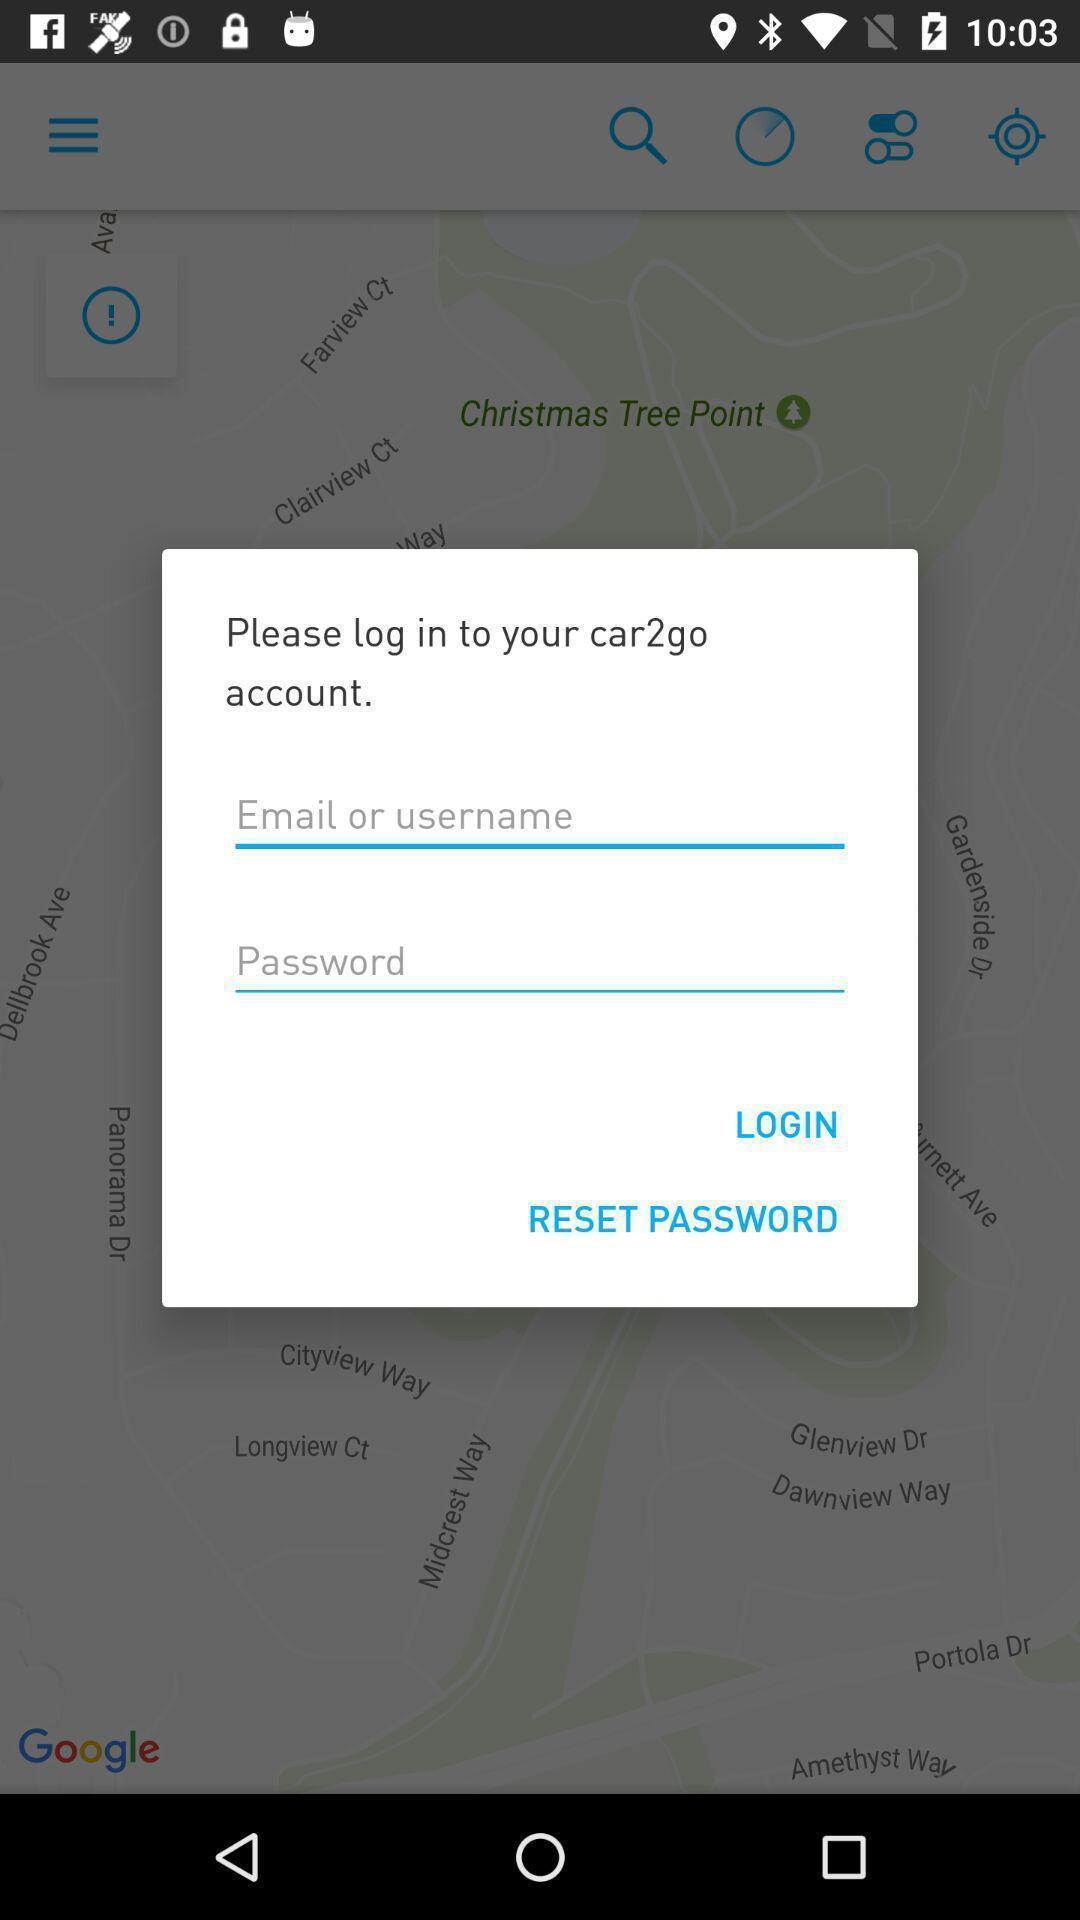Summarize the main components in this picture. Pop-up with login options in a car rental app. 